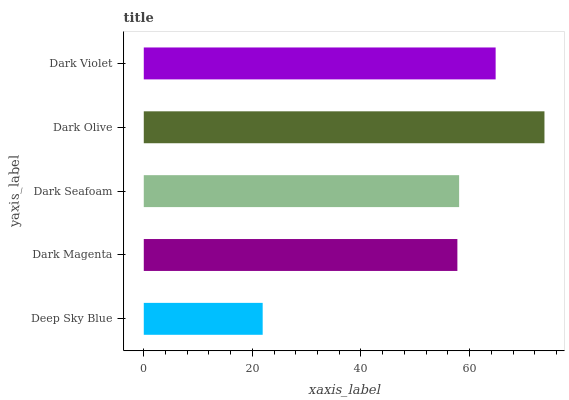Is Deep Sky Blue the minimum?
Answer yes or no. Yes. Is Dark Olive the maximum?
Answer yes or no. Yes. Is Dark Magenta the minimum?
Answer yes or no. No. Is Dark Magenta the maximum?
Answer yes or no. No. Is Dark Magenta greater than Deep Sky Blue?
Answer yes or no. Yes. Is Deep Sky Blue less than Dark Magenta?
Answer yes or no. Yes. Is Deep Sky Blue greater than Dark Magenta?
Answer yes or no. No. Is Dark Magenta less than Deep Sky Blue?
Answer yes or no. No. Is Dark Seafoam the high median?
Answer yes or no. Yes. Is Dark Seafoam the low median?
Answer yes or no. Yes. Is Dark Violet the high median?
Answer yes or no. No. Is Dark Magenta the low median?
Answer yes or no. No. 